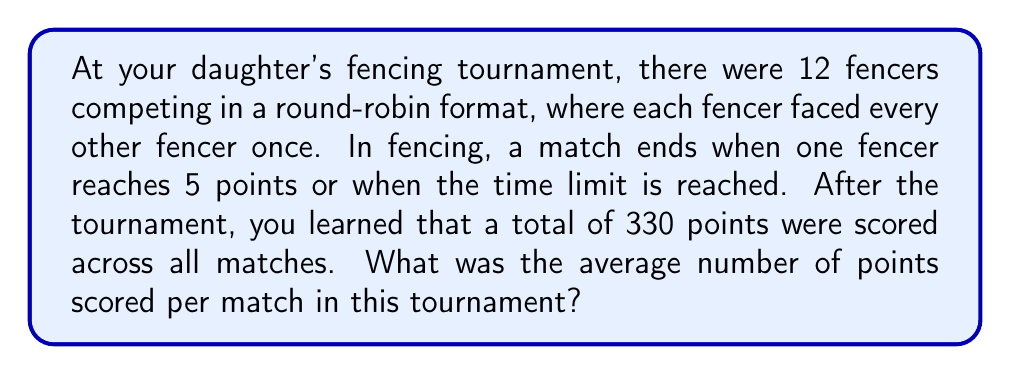Give your solution to this math problem. Let's approach this step-by-step:

1) First, we need to calculate the total number of matches in the tournament.
   In a round-robin tournament with $n$ fencers, the number of matches is:
   
   $$\text{Number of matches} = \frac{n(n-1)}{2}$$

   With 12 fencers: $\frac{12(12-1)}{2} = \frac{12 \times 11}{2} = 66$ matches

2) We're given that the total number of points scored in the tournament was 330.

3) To find the average number of points per match, we divide the total points by the number of matches:

   $$\text{Average points per match} = \frac{\text{Total points}}{\text{Number of matches}}$$

   $$\text{Average points per match} = \frac{330}{66}$$

4) Simplifying this fraction:
   
   $$\frac{330}{66} = 5$$

Therefore, the average number of points scored per match was 5.

This makes sense in the context of fencing, as matches often end when one fencer reaches 5 points. Some matches might have fewer points if the time limit is reached, while others might have more than 5 if the score was close (like 5-4), balancing out to an average of 5 points per match.
Answer: $5$ points per match 